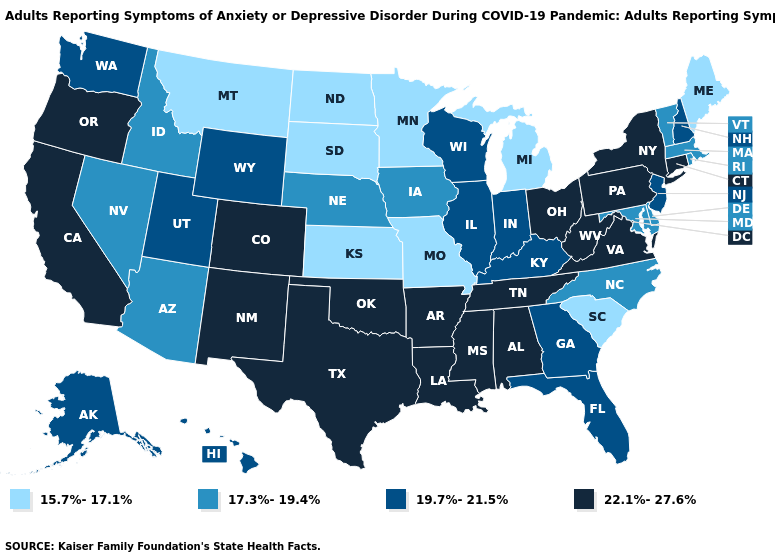What is the value of Montana?
Short answer required. 15.7%-17.1%. What is the value of Idaho?
Be succinct. 17.3%-19.4%. Among the states that border Indiana , does Ohio have the highest value?
Concise answer only. Yes. What is the highest value in the USA?
Concise answer only. 22.1%-27.6%. Which states have the highest value in the USA?
Be succinct. Alabama, Arkansas, California, Colorado, Connecticut, Louisiana, Mississippi, New Mexico, New York, Ohio, Oklahoma, Oregon, Pennsylvania, Tennessee, Texas, Virginia, West Virginia. Does Nevada have the highest value in the West?
Answer briefly. No. What is the value of Tennessee?
Short answer required. 22.1%-27.6%. Which states have the highest value in the USA?
Give a very brief answer. Alabama, Arkansas, California, Colorado, Connecticut, Louisiana, Mississippi, New Mexico, New York, Ohio, Oklahoma, Oregon, Pennsylvania, Tennessee, Texas, Virginia, West Virginia. Does South Carolina have a lower value than Indiana?
Write a very short answer. Yes. Does New York have the same value as New Mexico?
Short answer required. Yes. Does Mississippi have the lowest value in the USA?
Be succinct. No. Name the states that have a value in the range 17.3%-19.4%?
Concise answer only. Arizona, Delaware, Idaho, Iowa, Maryland, Massachusetts, Nebraska, Nevada, North Carolina, Rhode Island, Vermont. Name the states that have a value in the range 22.1%-27.6%?
Answer briefly. Alabama, Arkansas, California, Colorado, Connecticut, Louisiana, Mississippi, New Mexico, New York, Ohio, Oklahoma, Oregon, Pennsylvania, Tennessee, Texas, Virginia, West Virginia. Does the first symbol in the legend represent the smallest category?
Answer briefly. Yes. 